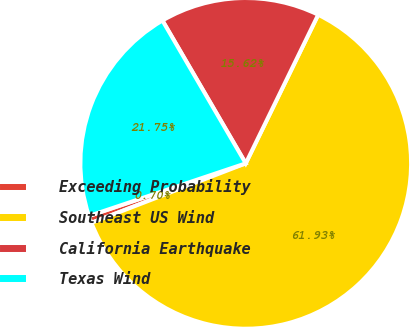Convert chart. <chart><loc_0><loc_0><loc_500><loc_500><pie_chart><fcel>Exceeding Probability<fcel>Southeast US Wind<fcel>California Earthquake<fcel>Texas Wind<nl><fcel>0.7%<fcel>61.93%<fcel>15.62%<fcel>21.75%<nl></chart> 